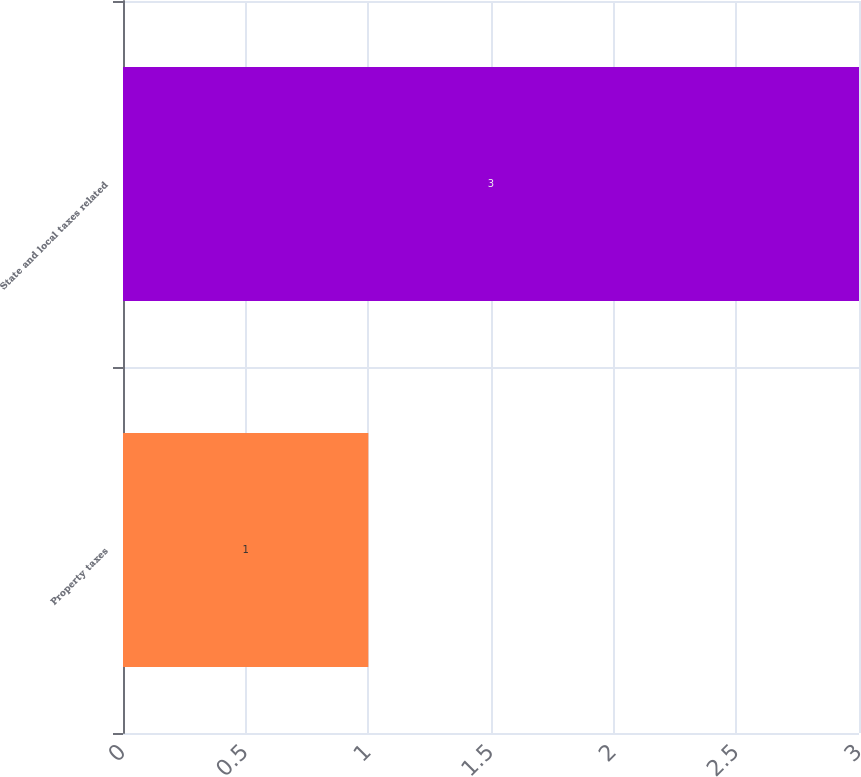<chart> <loc_0><loc_0><loc_500><loc_500><bar_chart><fcel>Property taxes<fcel>State and local taxes related<nl><fcel>1<fcel>3<nl></chart> 